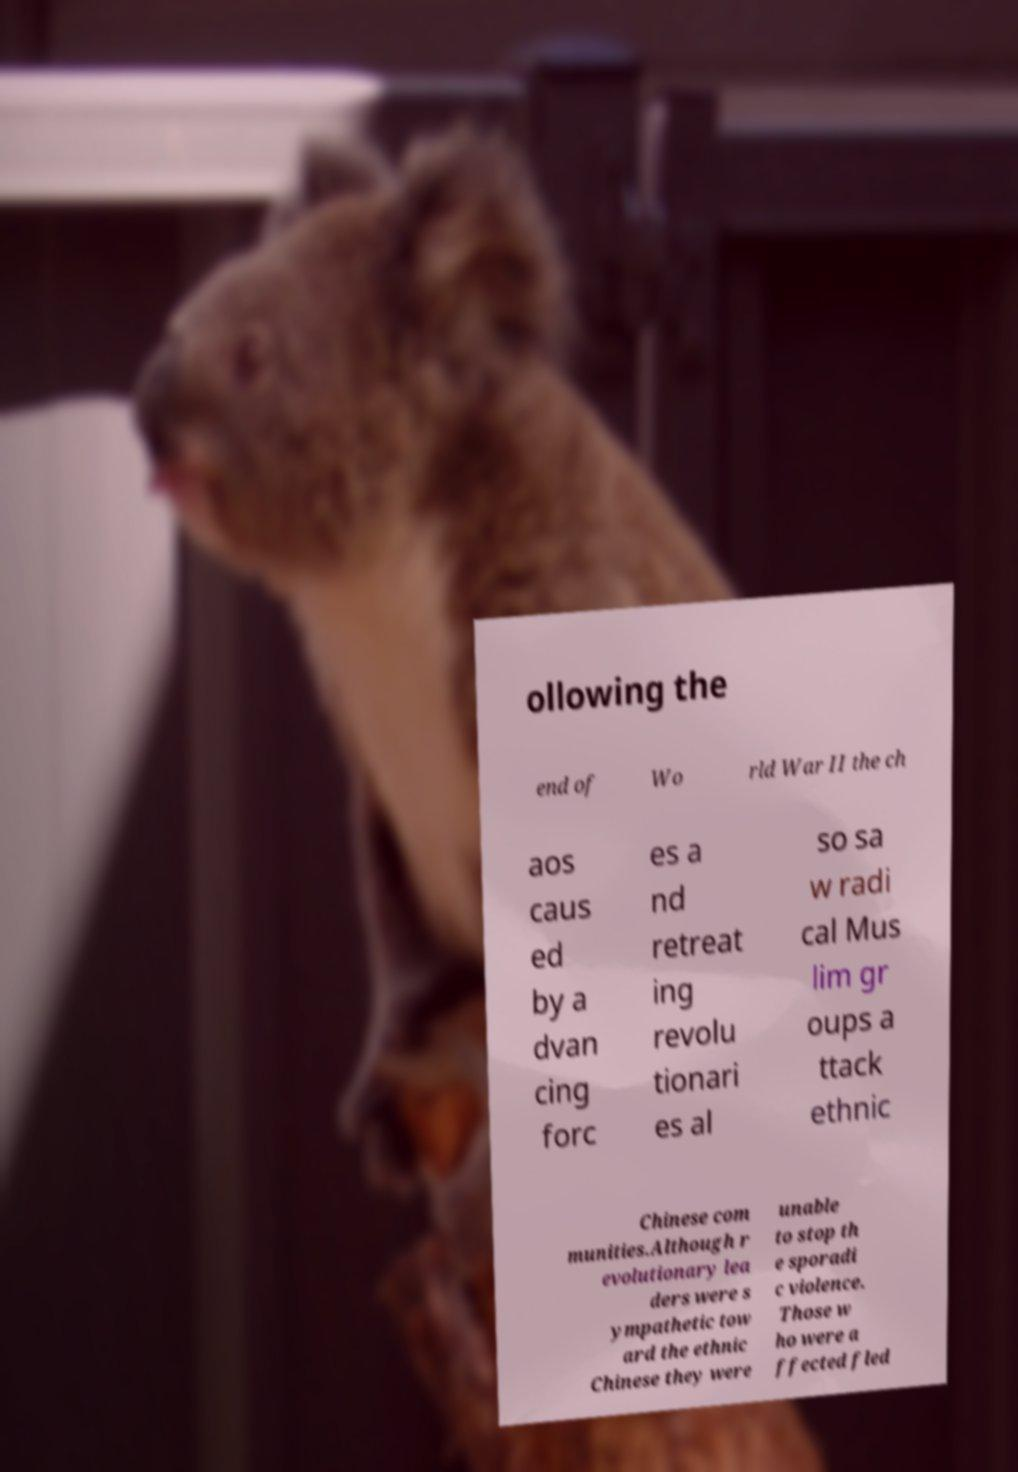Could you assist in decoding the text presented in this image and type it out clearly? ollowing the end of Wo rld War II the ch aos caus ed by a dvan cing forc es a nd retreat ing revolu tionari es al so sa w radi cal Mus lim gr oups a ttack ethnic Chinese com munities.Although r evolutionary lea ders were s ympathetic tow ard the ethnic Chinese they were unable to stop th e sporadi c violence. Those w ho were a ffected fled 